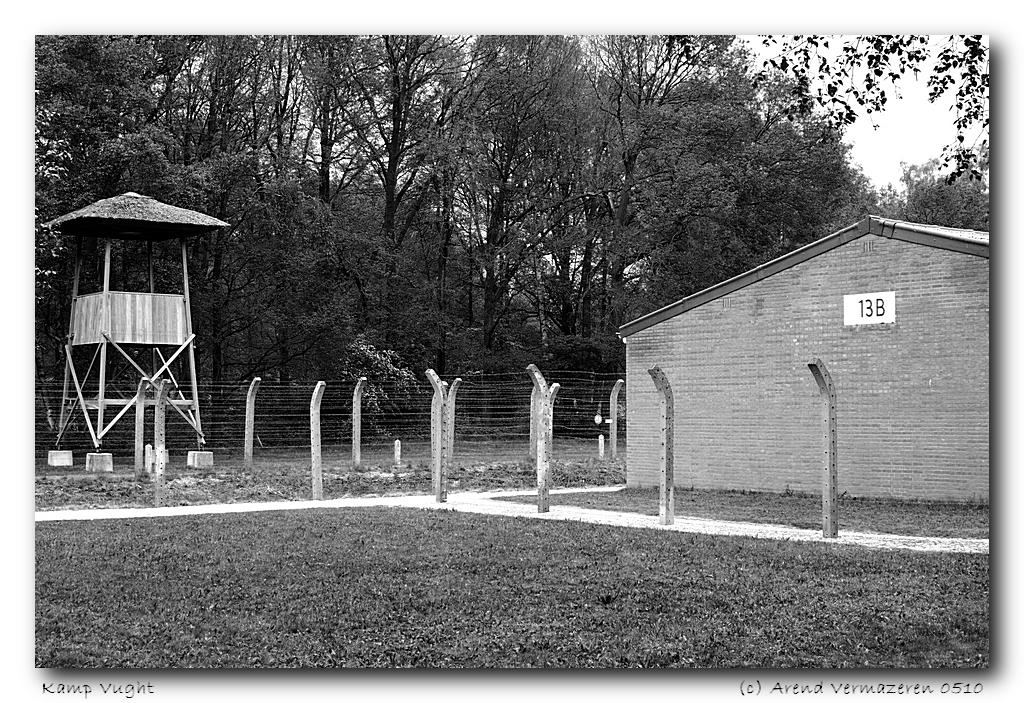What type of structure is surrounded by the barbed wire fence in the image? There is a house inside a barbed wire fence in the image. What can be seen on the other side of the fence? There are trees and a hut on the other side of the fence. What type of pancake is being served in the hut on the other side of the fence? There is no pancake visible in the image, nor is there any indication of food being served. 